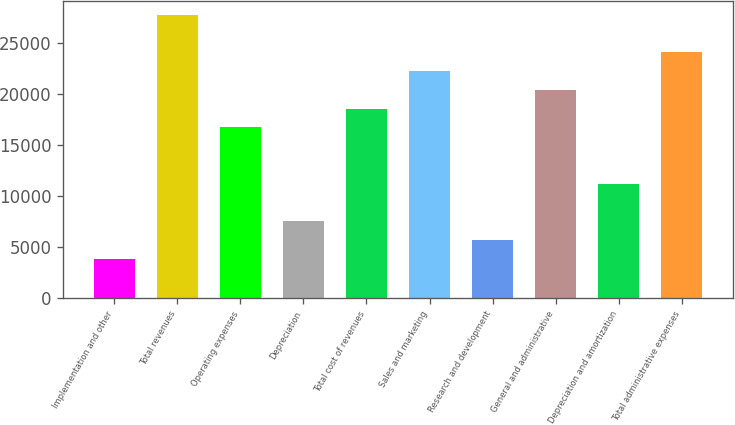<chart> <loc_0><loc_0><loc_500><loc_500><bar_chart><fcel>Implementation and other<fcel>Total revenues<fcel>Operating expenses<fcel>Depreciation<fcel>Total cost of revenues<fcel>Sales and marketing<fcel>Research and development<fcel>General and administrative<fcel>Depreciation and amortization<fcel>Total administrative expenses<nl><fcel>3834.4<fcel>27776.5<fcel>16726.3<fcel>7517.8<fcel>18568<fcel>22251.4<fcel>5676.1<fcel>20409.7<fcel>11201.2<fcel>24093.1<nl></chart> 